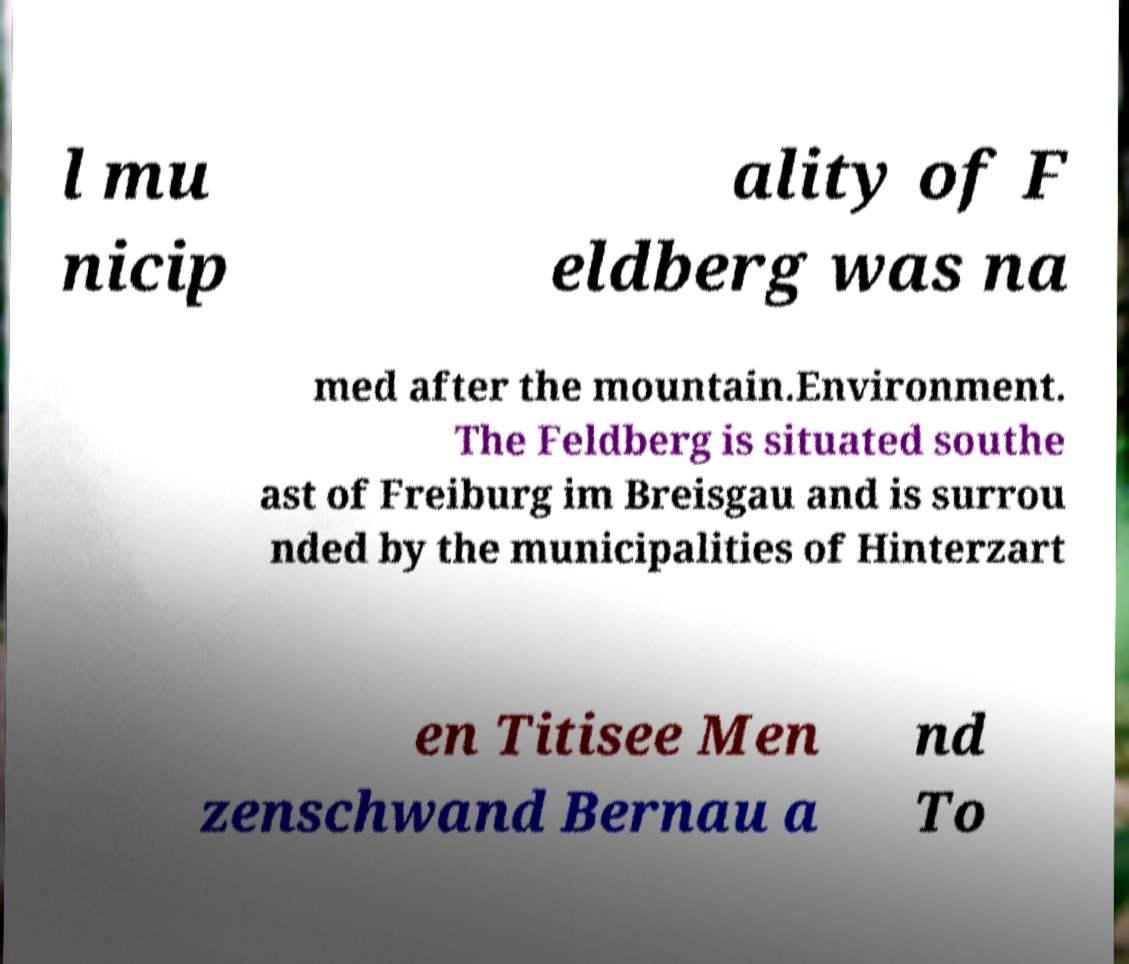Please read and relay the text visible in this image. What does it say? l mu nicip ality of F eldberg was na med after the mountain.Environment. The Feldberg is situated southe ast of Freiburg im Breisgau and is surrou nded by the municipalities of Hinterzart en Titisee Men zenschwand Bernau a nd To 